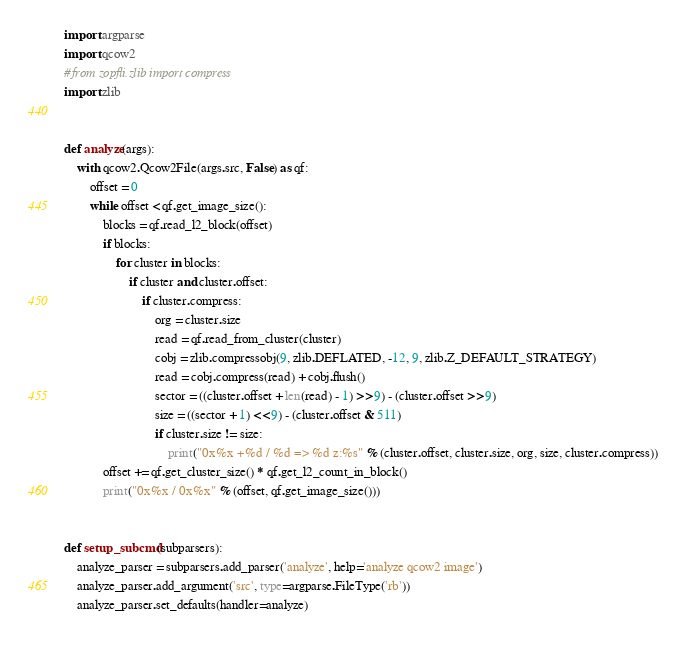<code> <loc_0><loc_0><loc_500><loc_500><_Python_>import argparse
import qcow2
#from zopfli.zlib import compress
import zlib


def analyze(args):
    with qcow2.Qcow2File(args.src, False) as qf:
        offset = 0
        while offset < qf.get_image_size():
            blocks = qf.read_l2_block(offset)
            if blocks:
                for cluster in blocks:
                    if cluster and cluster.offset:
                        if cluster.compress:
                            org = cluster.size
                            read = qf.read_from_cluster(cluster)
                            cobj = zlib.compressobj(9, zlib.DEFLATED, -12, 9, zlib.Z_DEFAULT_STRATEGY)
                            read = cobj.compress(read) + cobj.flush()
                            sector = ((cluster.offset + len(read) - 1) >> 9) - (cluster.offset >> 9)
                            size = ((sector + 1) << 9) - (cluster.offset & 511)
                            if cluster.size != size:
                                print("0x%x +%d / %d => %d z:%s" % (cluster.offset, cluster.size, org, size, cluster.compress))
            offset += qf.get_cluster_size() * qf.get_l2_count_in_block()
            print("0x%x / 0x%x" % (offset, qf.get_image_size()))


def setup_subcmd(subparsers):
    analyze_parser = subparsers.add_parser('analyze', help='analyze qcow2 image')
    analyze_parser.add_argument('src', type=argparse.FileType('rb'))
    analyze_parser.set_defaults(handler=analyze)
</code> 